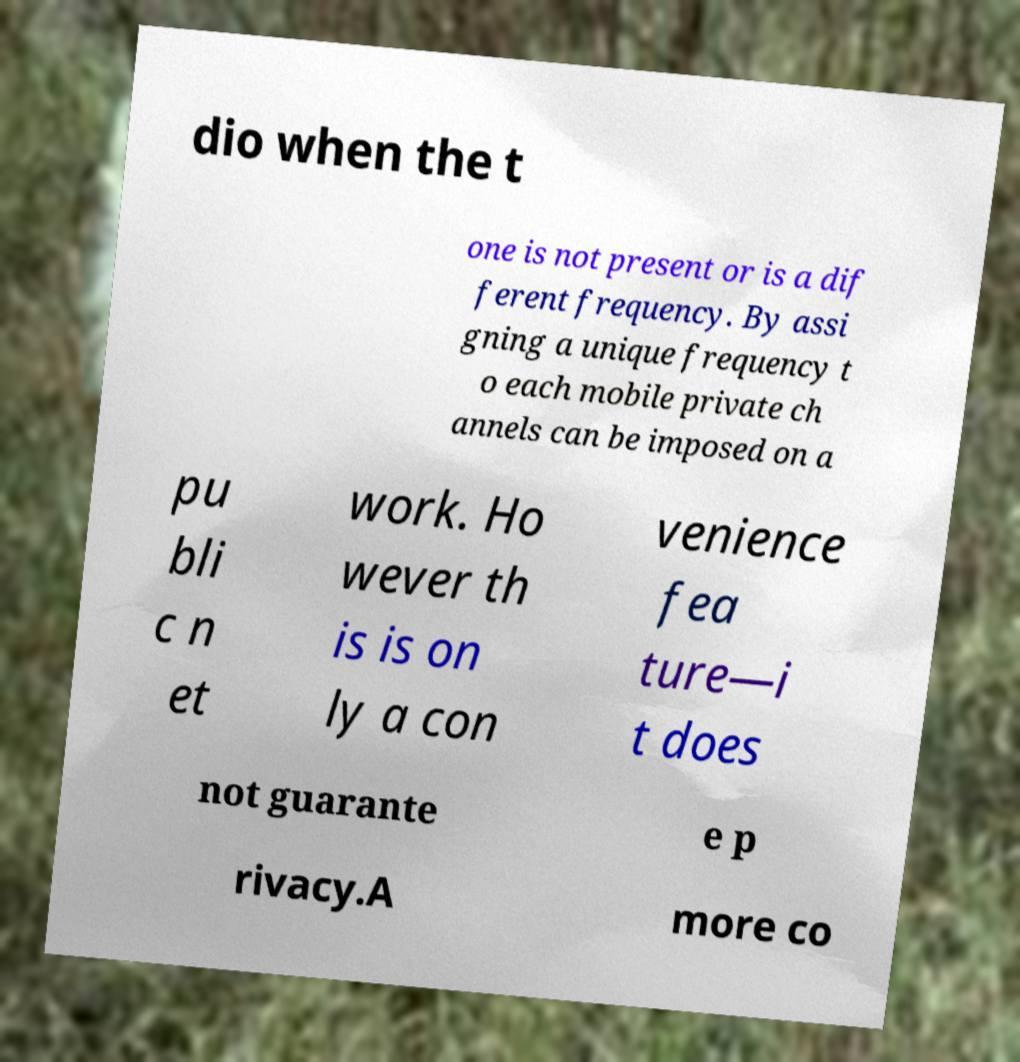Can you read and provide the text displayed in the image?This photo seems to have some interesting text. Can you extract and type it out for me? dio when the t one is not present or is a dif ferent frequency. By assi gning a unique frequency t o each mobile private ch annels can be imposed on a pu bli c n et work. Ho wever th is is on ly a con venience fea ture—i t does not guarante e p rivacy.A more co 